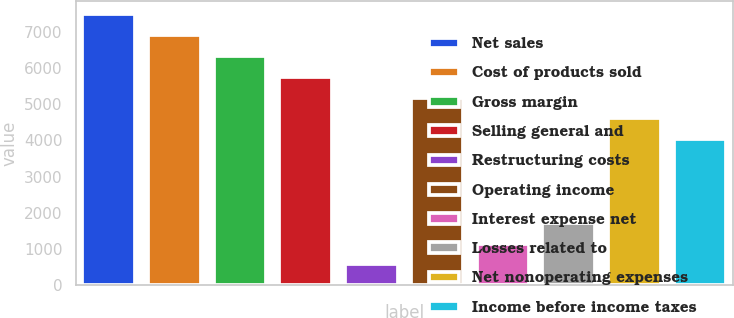Convert chart. <chart><loc_0><loc_0><loc_500><loc_500><bar_chart><fcel>Net sales<fcel>Cost of products sold<fcel>Gross margin<fcel>Selling general and<fcel>Restructuring costs<fcel>Operating income<fcel>Interest expense net<fcel>Losses related to<fcel>Net nonoperating expenses<fcel>Income before income taxes<nl><fcel>7484.71<fcel>6909.54<fcel>6334.37<fcel>5759.2<fcel>582.67<fcel>5184.03<fcel>1157.84<fcel>1733.01<fcel>4608.86<fcel>4033.69<nl></chart> 